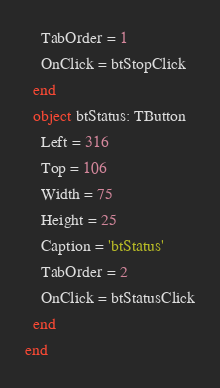<code> <loc_0><loc_0><loc_500><loc_500><_Pascal_>    TabOrder = 1
    OnClick = btStopClick
  end
  object btStatus: TButton
    Left = 316
    Top = 106
    Width = 75
    Height = 25
    Caption = 'btStatus'
    TabOrder = 2
    OnClick = btStatusClick
  end
end
</code> 